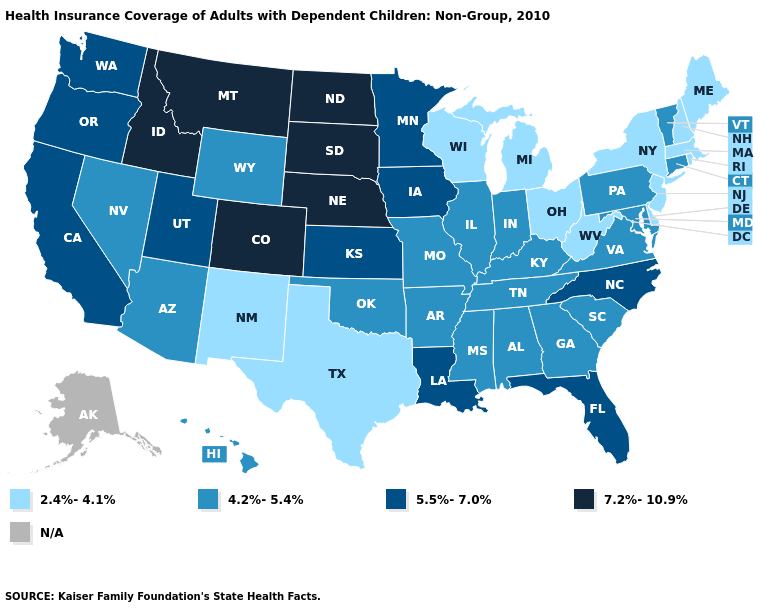Does Arizona have the lowest value in the USA?
Answer briefly. No. Is the legend a continuous bar?
Short answer required. No. Name the states that have a value in the range 5.5%-7.0%?
Keep it brief. California, Florida, Iowa, Kansas, Louisiana, Minnesota, North Carolina, Oregon, Utah, Washington. What is the lowest value in the USA?
Concise answer only. 2.4%-4.1%. Name the states that have a value in the range 4.2%-5.4%?
Give a very brief answer. Alabama, Arizona, Arkansas, Connecticut, Georgia, Hawaii, Illinois, Indiana, Kentucky, Maryland, Mississippi, Missouri, Nevada, Oklahoma, Pennsylvania, South Carolina, Tennessee, Vermont, Virginia, Wyoming. Name the states that have a value in the range N/A?
Give a very brief answer. Alaska. What is the lowest value in states that border Missouri?
Concise answer only. 4.2%-5.4%. Name the states that have a value in the range 2.4%-4.1%?
Concise answer only. Delaware, Maine, Massachusetts, Michigan, New Hampshire, New Jersey, New Mexico, New York, Ohio, Rhode Island, Texas, West Virginia, Wisconsin. Does South Dakota have the highest value in the USA?
Quick response, please. Yes. Among the states that border Mississippi , does Alabama have the lowest value?
Answer briefly. Yes. Name the states that have a value in the range 5.5%-7.0%?
Keep it brief. California, Florida, Iowa, Kansas, Louisiana, Minnesota, North Carolina, Oregon, Utah, Washington. Name the states that have a value in the range N/A?
Write a very short answer. Alaska. Does West Virginia have the lowest value in the South?
Write a very short answer. Yes. 